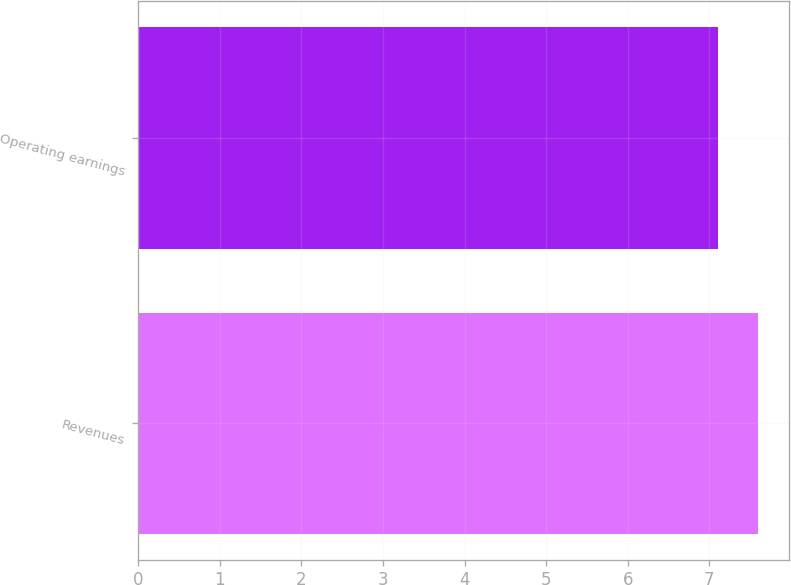<chart> <loc_0><loc_0><loc_500><loc_500><bar_chart><fcel>Revenues<fcel>Operating earnings<nl><fcel>7.6<fcel>7.1<nl></chart> 